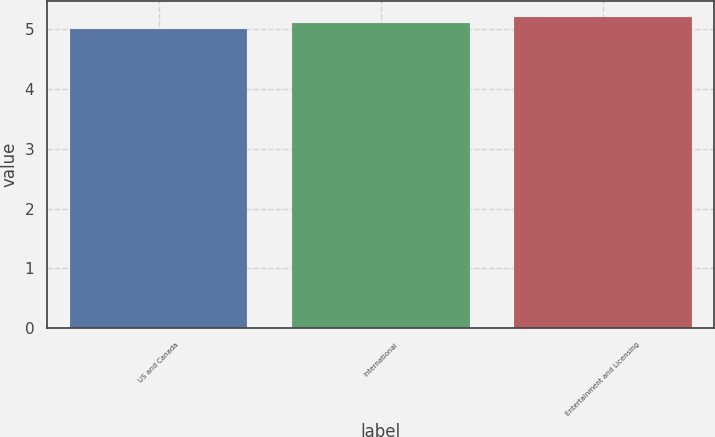<chart> <loc_0><loc_0><loc_500><loc_500><bar_chart><fcel>US and Canada<fcel>International<fcel>Entertainment and Licensing<nl><fcel>5<fcel>5.1<fcel>5.2<nl></chart> 